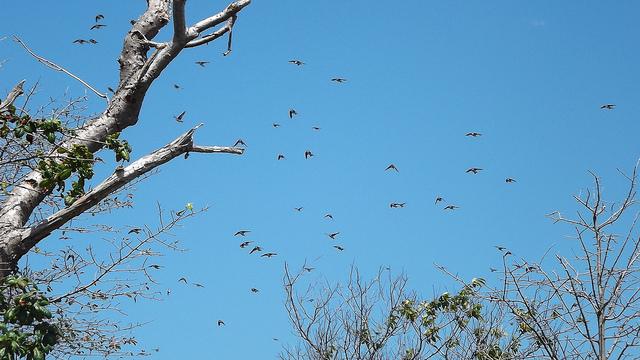Does the tree have leaves on it?
Answer briefly. Yes. Are the branches bent up or down?
Be succinct. Up. What is in the sky?
Be succinct. Birds. What is the bird on?
Quick response, please. Tree. Is the bird alone?
Short answer required. No. Is the bird flying?
Quick response, please. Yes. Is this animal flying?
Keep it brief. Yes. How many birds on the tree?
Quick response, please. 0. Are these bats?
Short answer required. No. Is it overcast?
Quick response, please. No. 